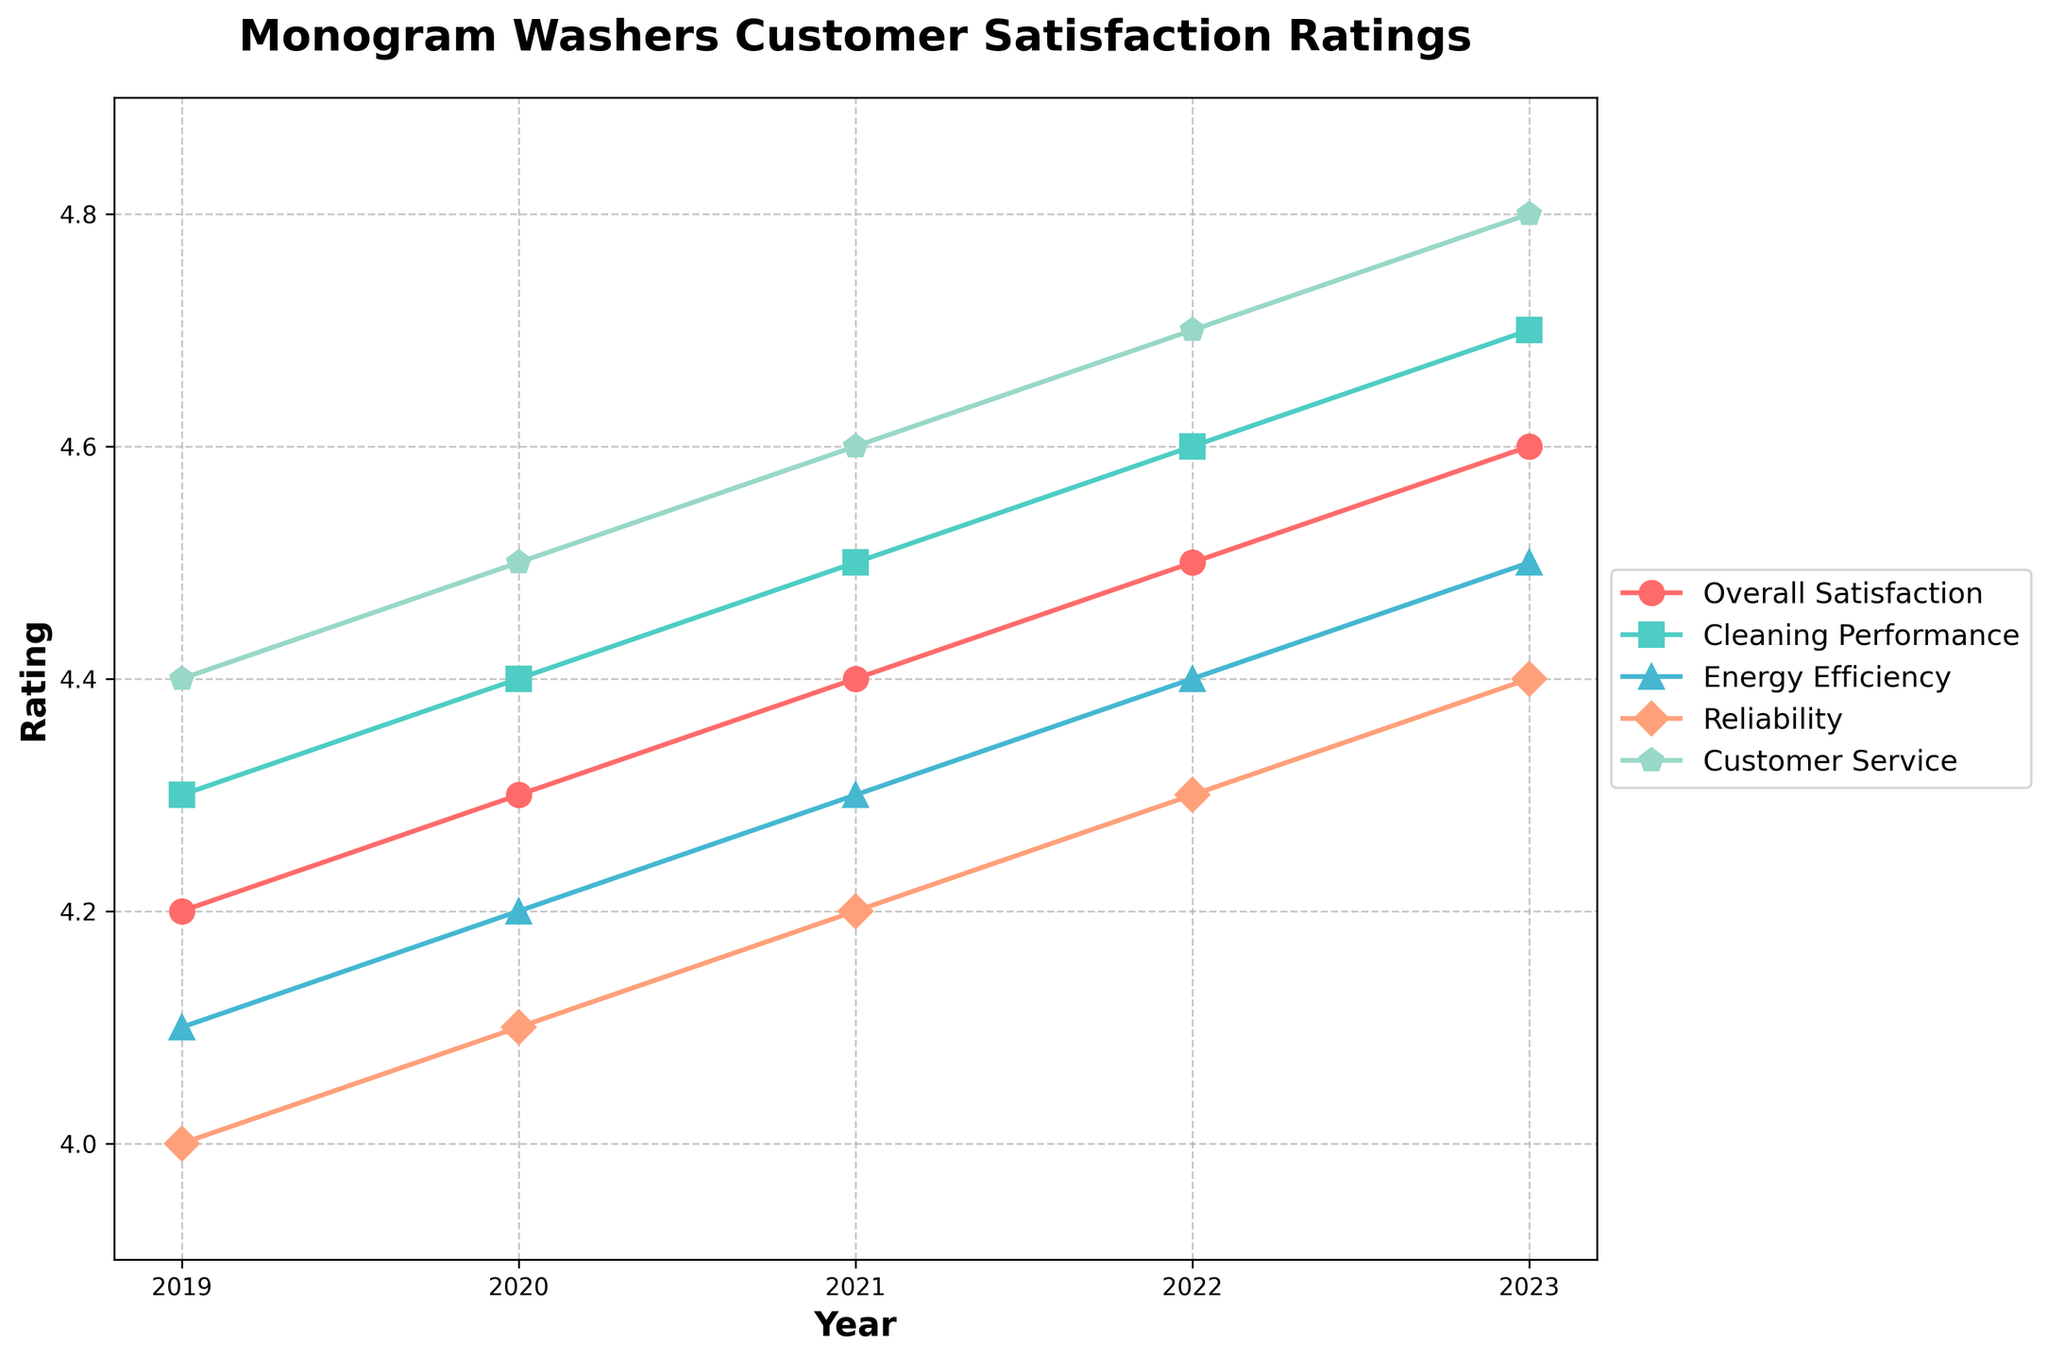What's the overall trend in the 'Customer Service' satisfaction rating from 2019 to 2023? Looking at the line representing 'Customer Service' from 2019 to 2023, we see a consistent upward trend with ratings increasing year by year.
Answer: Increasing Which category showed the least improvement in satisfaction ratings over the 5-year period? By calculating the difference between the 2023 and 2019 rating for each category, 'Reliability' improved the least (4.4 - 4.0 = 0.4). The remaining categories increased more.
Answer: Reliability Which year had the highest overall satisfaction rating? Refer to the 'Overall Satisfaction' line and observe the data points. The highest rating is in 2023, standing at 4.6.
Answer: 2023 By how much did the 'Energy Efficiency' rating improve from 2019 to 2023? Subtract the 2019 'Energy Efficiency' rating from the 2023 rating: 4.5 - 4.1 = 0.4.
Answer: 0.4 In 2022, which category had the second-highest satisfaction rating? Looking at the 2022 data points, the 'Customer Service' category had the highest rating (4.7), and 'Cleaning Performance' had the second-highest (4.6).
Answer: Cleaning Performance Which category had the steepest increase in ratings between 2020 and 2021? Calculate the differences for each category between 2020 and 2021. 'Customer Service' increased by 0.1, which is the highest increment among all categories.
Answer: Customer Service How do the ratings for 'Reliability' and 'Cleaning Performance' in 2023 compare? Compare the data points in 2023 for both categories: 'Reliability' is at 4.4 and 'Cleaning Performance' is at 4.7. Thus, 'Cleaning Performance' is rated higher.
Answer: Cleaning Performance is higher What is the average 'Overall Satisfaction' rating over the 5 years? Sum the 'Overall Satisfaction' ratings and divide by 5: (4.2 + 4.3 + 4.4 + 4.5 + 4.6) / 5 = 22 / 5 = 4.4.
Answer: 4.4 If a customer values 'Energy Efficiency' and 'Reliability' equally, what is the combined rating for these categories in 2022? Add the 2022 ratings for 'Energy Efficiency' (4.4) and 'Reliability' (4.3): 4.4 + 4.3 = 8.7.
Answer: 8.7 